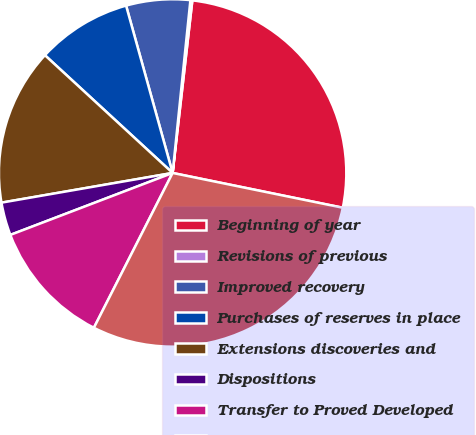Convert chart to OTSL. <chart><loc_0><loc_0><loc_500><loc_500><pie_chart><fcel>Beginning of year<fcel>Revisions of previous<fcel>Improved recovery<fcel>Purchases of reserves in place<fcel>Extensions discoveries and<fcel>Dispositions<fcel>Transfer to Proved Developed<fcel>End of year<nl><fcel>26.4%<fcel>0.18%<fcel>5.95%<fcel>8.83%<fcel>14.59%<fcel>3.07%<fcel>11.71%<fcel>29.28%<nl></chart> 